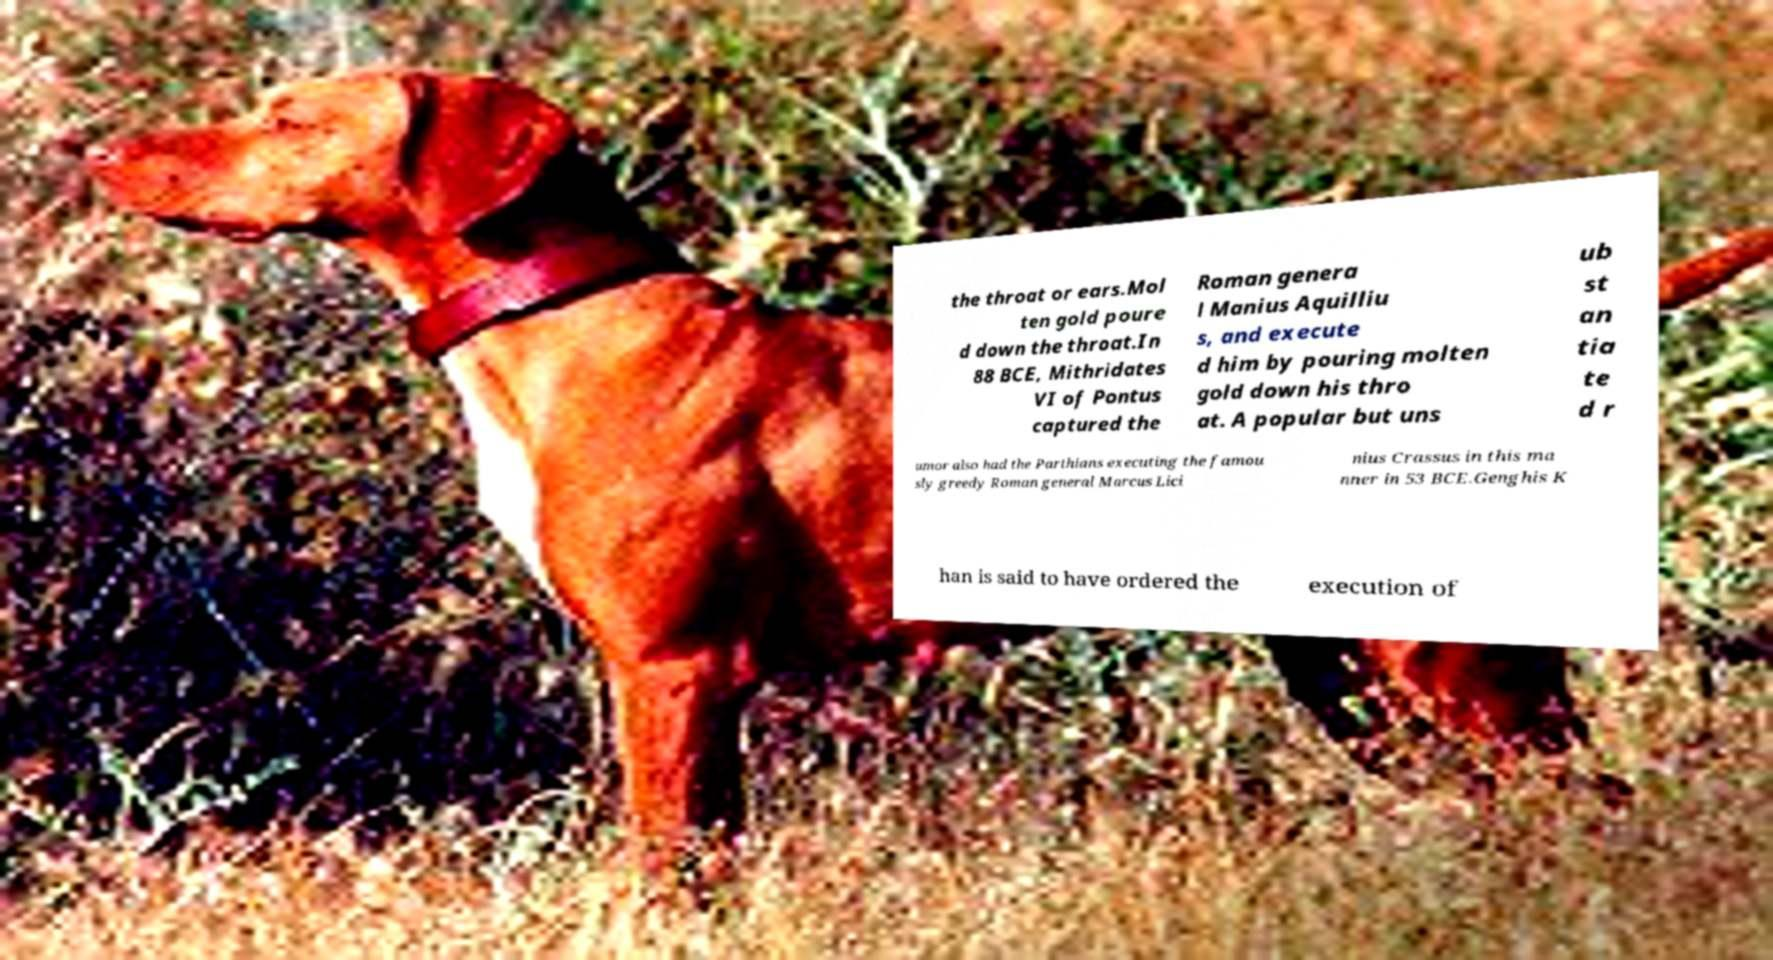Can you accurately transcribe the text from the provided image for me? the throat or ears.Mol ten gold poure d down the throat.In 88 BCE, Mithridates VI of Pontus captured the Roman genera l Manius Aquilliu s, and execute d him by pouring molten gold down his thro at. A popular but uns ub st an tia te d r umor also had the Parthians executing the famou sly greedy Roman general Marcus Lici nius Crassus in this ma nner in 53 BCE.Genghis K han is said to have ordered the execution of 